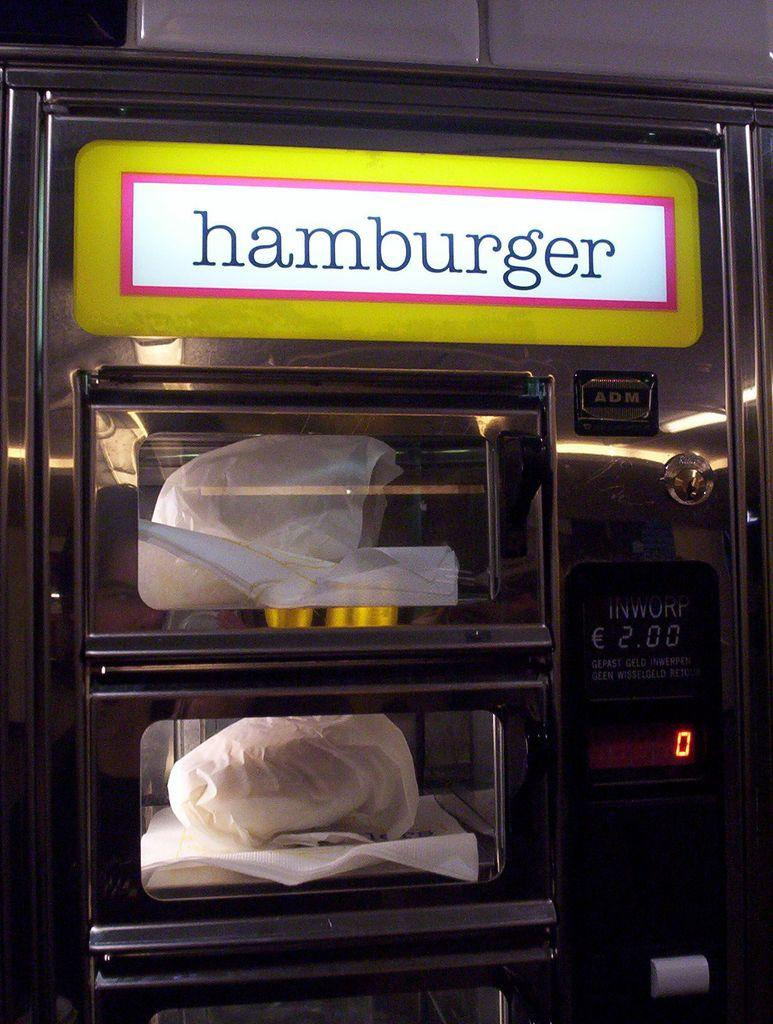<image>
Create a compact narrative representing the image presented. A hamburger vending machine where each costs two pounds. 